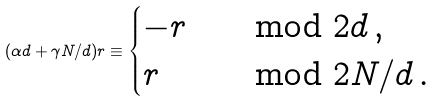<formula> <loc_0><loc_0><loc_500><loc_500>( \alpha d + \gamma N / d ) r \equiv \begin{cases} - r & \mod { 2 d } \, , \\ r & \mod { 2 N / d } \, . \end{cases}</formula> 